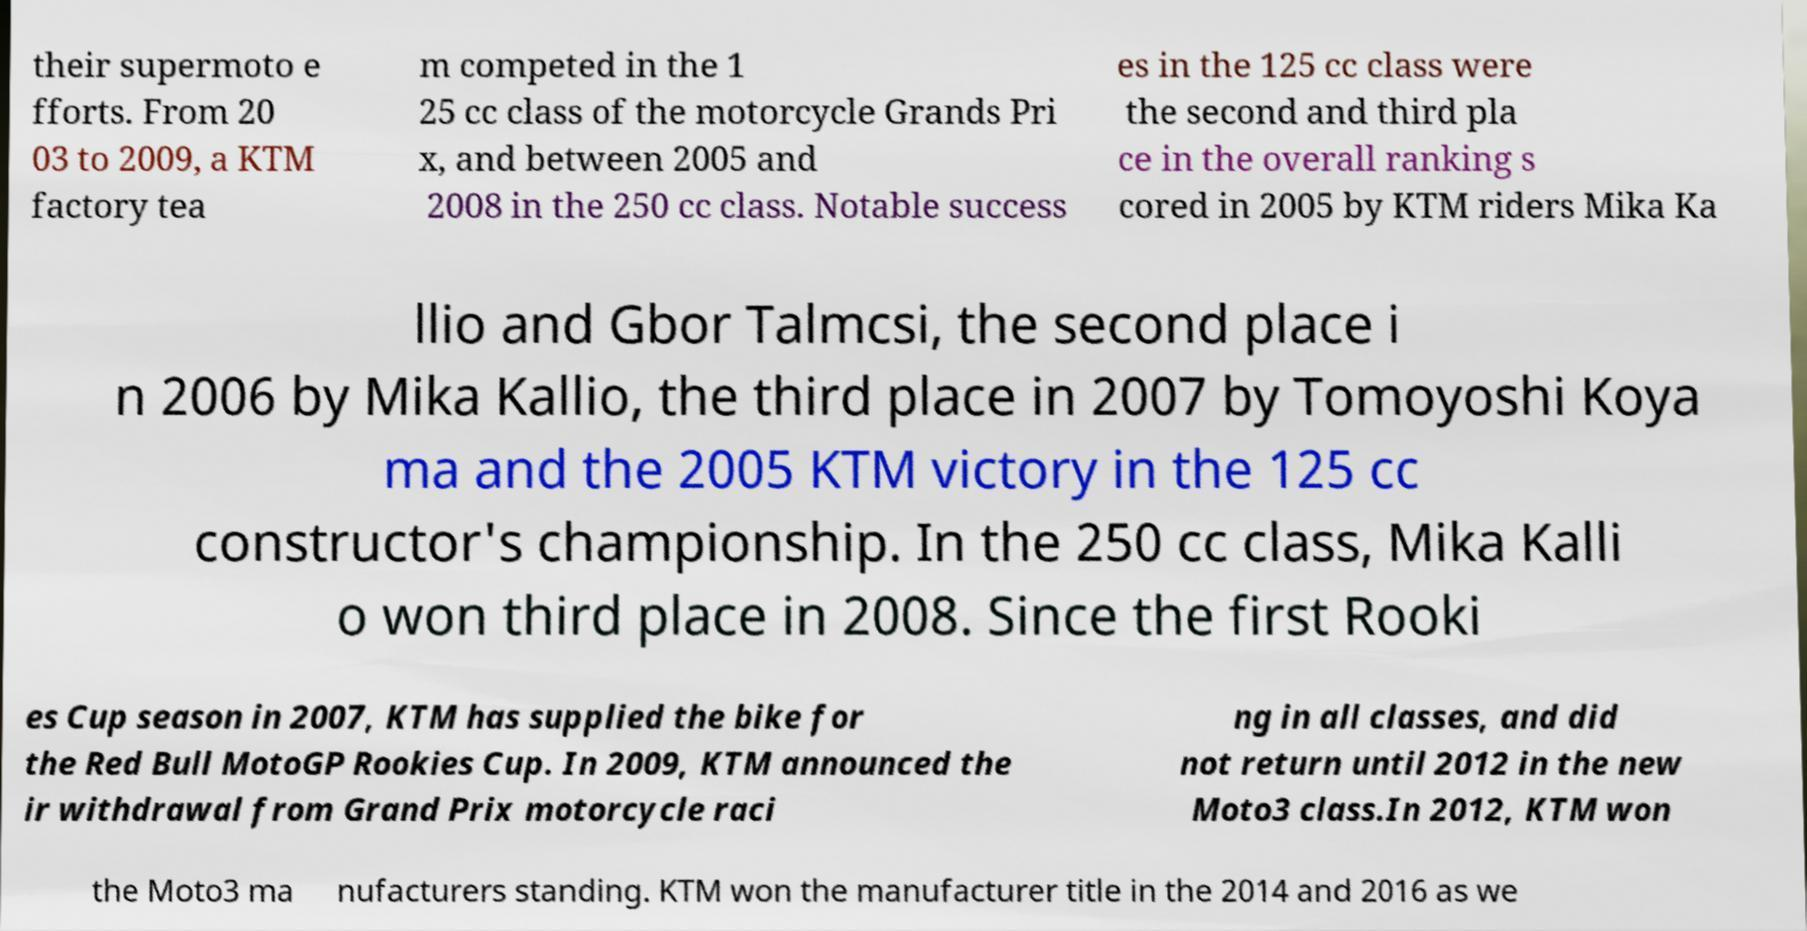Could you assist in decoding the text presented in this image and type it out clearly? their supermoto e fforts. From 20 03 to 2009, a KTM factory tea m competed in the 1 25 cc class of the motorcycle Grands Pri x, and between 2005 and 2008 in the 250 cc class. Notable success es in the 125 cc class were the second and third pla ce in the overall ranking s cored in 2005 by KTM riders Mika Ka llio and Gbor Talmcsi, the second place i n 2006 by Mika Kallio, the third place in 2007 by Tomoyoshi Koya ma and the 2005 KTM victory in the 125 cc constructor's championship. In the 250 cc class, Mika Kalli o won third place in 2008. Since the first Rooki es Cup season in 2007, KTM has supplied the bike for the Red Bull MotoGP Rookies Cup. In 2009, KTM announced the ir withdrawal from Grand Prix motorcycle raci ng in all classes, and did not return until 2012 in the new Moto3 class.In 2012, KTM won the Moto3 ma nufacturers standing. KTM won the manufacturer title in the 2014 and 2016 as we 